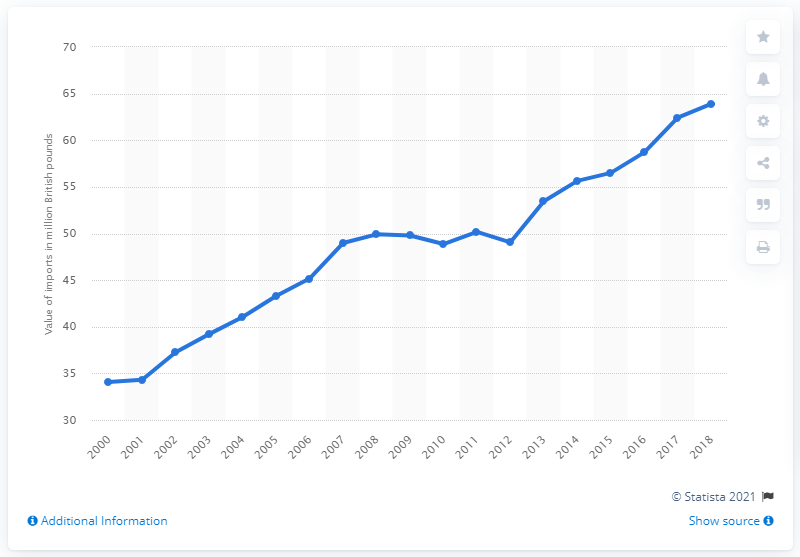Highlight a few significant elements in this photo. In 2018, the value of UK imports was 63.91. In 2000, the value of UK imports was 34.31. 